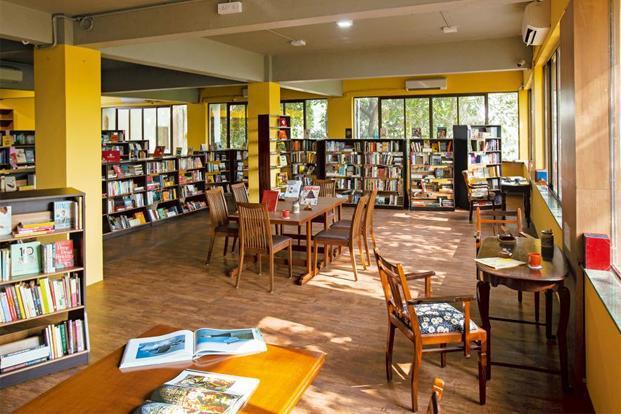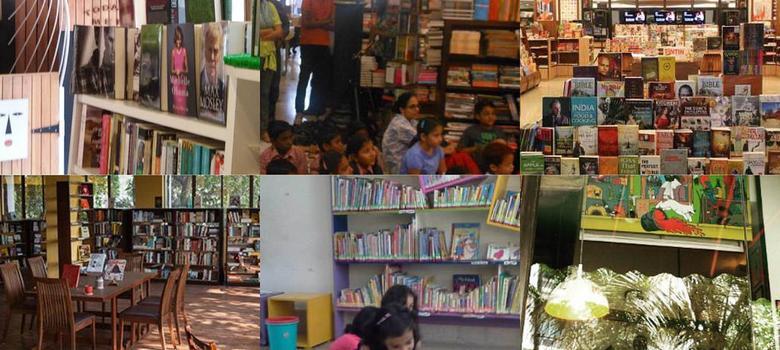The first image is the image on the left, the second image is the image on the right. Assess this claim about the two images: "A sign with the name of the bookstore hangs over the store's entrance.". Correct or not? Answer yes or no. No. The first image is the image on the left, the second image is the image on the right. Considering the images on both sides, is "Next to at least 4 stacks of books there are two black poles painted gold towards the middle." valid? Answer yes or no. No. 